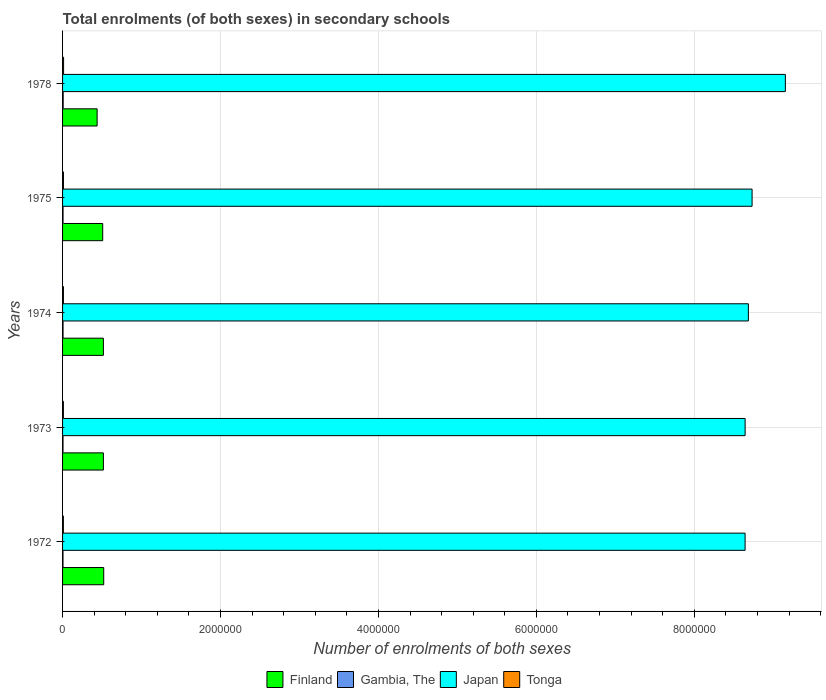How many bars are there on the 4th tick from the top?
Offer a terse response. 4. How many bars are there on the 4th tick from the bottom?
Your answer should be compact. 4. What is the label of the 2nd group of bars from the top?
Your response must be concise. 1975. What is the number of enrolments in secondary schools in Tonga in 1972?
Provide a succinct answer. 1.04e+04. Across all years, what is the maximum number of enrolments in secondary schools in Tonga?
Keep it short and to the point. 1.28e+04. Across all years, what is the minimum number of enrolments in secondary schools in Finland?
Keep it short and to the point. 4.38e+05. In which year was the number of enrolments in secondary schools in Japan maximum?
Make the answer very short. 1978. What is the total number of enrolments in secondary schools in Gambia, The in the graph?
Provide a short and direct response. 3.10e+04. What is the difference between the number of enrolments in secondary schools in Finland in 1973 and that in 1974?
Your response must be concise. -25. What is the difference between the number of enrolments in secondary schools in Gambia, The in 1973 and the number of enrolments in secondary schools in Tonga in 1972?
Make the answer very short. -4580. What is the average number of enrolments in secondary schools in Finland per year?
Provide a short and direct response. 5.00e+05. In the year 1975, what is the difference between the number of enrolments in secondary schools in Finland and number of enrolments in secondary schools in Gambia, The?
Offer a very short reply. 5.02e+05. In how many years, is the number of enrolments in secondary schools in Japan greater than 400000 ?
Keep it short and to the point. 5. What is the ratio of the number of enrolments in secondary schools in Japan in 1972 to that in 1974?
Keep it short and to the point. 1. Is the number of enrolments in secondary schools in Tonga in 1973 less than that in 1975?
Ensure brevity in your answer.  Yes. Is the difference between the number of enrolments in secondary schools in Finland in 1974 and 1978 greater than the difference between the number of enrolments in secondary schools in Gambia, The in 1974 and 1978?
Provide a short and direct response. Yes. What is the difference between the highest and the second highest number of enrolments in secondary schools in Tonga?
Ensure brevity in your answer.  1444. What is the difference between the highest and the lowest number of enrolments in secondary schools in Tonga?
Provide a short and direct response. 2424. Is the sum of the number of enrolments in secondary schools in Tonga in 1974 and 1975 greater than the maximum number of enrolments in secondary schools in Finland across all years?
Provide a short and direct response. No. What does the 3rd bar from the top in 1973 represents?
Give a very brief answer. Gambia, The. What does the 1st bar from the bottom in 1974 represents?
Offer a very short reply. Finland. Is it the case that in every year, the sum of the number of enrolments in secondary schools in Gambia, The and number of enrolments in secondary schools in Tonga is greater than the number of enrolments in secondary schools in Japan?
Offer a terse response. No. Are all the bars in the graph horizontal?
Your answer should be very brief. Yes. What is the difference between two consecutive major ticks on the X-axis?
Your response must be concise. 2.00e+06. Are the values on the major ticks of X-axis written in scientific E-notation?
Ensure brevity in your answer.  No. Does the graph contain grids?
Provide a succinct answer. Yes. What is the title of the graph?
Your answer should be very brief. Total enrolments (of both sexes) in secondary schools. What is the label or title of the X-axis?
Offer a terse response. Number of enrolments of both sexes. What is the Number of enrolments of both sexes in Finland in 1972?
Offer a very short reply. 5.21e+05. What is the Number of enrolments of both sexes in Gambia, The in 1972?
Offer a terse response. 5482. What is the Number of enrolments of both sexes in Japan in 1972?
Ensure brevity in your answer.  8.64e+06. What is the Number of enrolments of both sexes in Tonga in 1972?
Provide a succinct answer. 1.04e+04. What is the Number of enrolments of both sexes of Finland in 1973?
Provide a short and direct response. 5.17e+05. What is the Number of enrolments of both sexes in Gambia, The in 1973?
Offer a very short reply. 5791. What is the Number of enrolments of both sexes of Japan in 1973?
Your answer should be compact. 8.64e+06. What is the Number of enrolments of both sexes of Tonga in 1973?
Offer a very short reply. 1.06e+04. What is the Number of enrolments of both sexes in Finland in 1974?
Your response must be concise. 5.17e+05. What is the Number of enrolments of both sexes in Gambia, The in 1974?
Give a very brief answer. 5997. What is the Number of enrolments of both sexes of Japan in 1974?
Provide a short and direct response. 8.68e+06. What is the Number of enrolments of both sexes in Tonga in 1974?
Your answer should be compact. 1.11e+04. What is the Number of enrolments of both sexes in Finland in 1975?
Ensure brevity in your answer.  5.08e+05. What is the Number of enrolments of both sexes of Gambia, The in 1975?
Provide a succinct answer. 6162. What is the Number of enrolments of both sexes in Japan in 1975?
Provide a short and direct response. 8.73e+06. What is the Number of enrolments of both sexes of Tonga in 1975?
Your answer should be very brief. 1.14e+04. What is the Number of enrolments of both sexes of Finland in 1978?
Your answer should be very brief. 4.38e+05. What is the Number of enrolments of both sexes of Gambia, The in 1978?
Provide a short and direct response. 7588. What is the Number of enrolments of both sexes in Japan in 1978?
Your answer should be very brief. 9.15e+06. What is the Number of enrolments of both sexes in Tonga in 1978?
Ensure brevity in your answer.  1.28e+04. Across all years, what is the maximum Number of enrolments of both sexes in Finland?
Give a very brief answer. 5.21e+05. Across all years, what is the maximum Number of enrolments of both sexes in Gambia, The?
Keep it short and to the point. 7588. Across all years, what is the maximum Number of enrolments of both sexes in Japan?
Ensure brevity in your answer.  9.15e+06. Across all years, what is the maximum Number of enrolments of both sexes in Tonga?
Your answer should be compact. 1.28e+04. Across all years, what is the minimum Number of enrolments of both sexes of Finland?
Offer a terse response. 4.38e+05. Across all years, what is the minimum Number of enrolments of both sexes of Gambia, The?
Your response must be concise. 5482. Across all years, what is the minimum Number of enrolments of both sexes of Japan?
Your answer should be very brief. 8.64e+06. Across all years, what is the minimum Number of enrolments of both sexes of Tonga?
Your answer should be very brief. 1.04e+04. What is the total Number of enrolments of both sexes of Finland in the graph?
Provide a short and direct response. 2.50e+06. What is the total Number of enrolments of both sexes of Gambia, The in the graph?
Provide a short and direct response. 3.10e+04. What is the total Number of enrolments of both sexes in Japan in the graph?
Give a very brief answer. 4.39e+07. What is the total Number of enrolments of both sexes of Tonga in the graph?
Offer a very short reply. 5.61e+04. What is the difference between the Number of enrolments of both sexes in Finland in 1972 and that in 1973?
Offer a terse response. 4213. What is the difference between the Number of enrolments of both sexes of Gambia, The in 1972 and that in 1973?
Provide a short and direct response. -309. What is the difference between the Number of enrolments of both sexes in Japan in 1972 and that in 1973?
Give a very brief answer. -497. What is the difference between the Number of enrolments of both sexes of Tonga in 1972 and that in 1973?
Your response must be concise. -181. What is the difference between the Number of enrolments of both sexes of Finland in 1972 and that in 1974?
Your response must be concise. 4188. What is the difference between the Number of enrolments of both sexes in Gambia, The in 1972 and that in 1974?
Provide a short and direct response. -515. What is the difference between the Number of enrolments of both sexes of Japan in 1972 and that in 1974?
Your answer should be compact. -4.16e+04. What is the difference between the Number of enrolments of both sexes in Tonga in 1972 and that in 1974?
Offer a very short reply. -681. What is the difference between the Number of enrolments of both sexes of Finland in 1972 and that in 1975?
Give a very brief answer. 1.30e+04. What is the difference between the Number of enrolments of both sexes in Gambia, The in 1972 and that in 1975?
Keep it short and to the point. -680. What is the difference between the Number of enrolments of both sexes of Japan in 1972 and that in 1975?
Provide a short and direct response. -8.85e+04. What is the difference between the Number of enrolments of both sexes of Tonga in 1972 and that in 1975?
Provide a short and direct response. -980. What is the difference between the Number of enrolments of both sexes in Finland in 1972 and that in 1978?
Your answer should be compact. 8.35e+04. What is the difference between the Number of enrolments of both sexes of Gambia, The in 1972 and that in 1978?
Keep it short and to the point. -2106. What is the difference between the Number of enrolments of both sexes of Japan in 1972 and that in 1978?
Give a very brief answer. -5.10e+05. What is the difference between the Number of enrolments of both sexes in Tonga in 1972 and that in 1978?
Offer a terse response. -2424. What is the difference between the Number of enrolments of both sexes of Finland in 1973 and that in 1974?
Give a very brief answer. -25. What is the difference between the Number of enrolments of both sexes of Gambia, The in 1973 and that in 1974?
Your answer should be compact. -206. What is the difference between the Number of enrolments of both sexes in Japan in 1973 and that in 1974?
Make the answer very short. -4.11e+04. What is the difference between the Number of enrolments of both sexes of Tonga in 1973 and that in 1974?
Your response must be concise. -500. What is the difference between the Number of enrolments of both sexes in Finland in 1973 and that in 1975?
Your response must be concise. 8749. What is the difference between the Number of enrolments of both sexes of Gambia, The in 1973 and that in 1975?
Ensure brevity in your answer.  -371. What is the difference between the Number of enrolments of both sexes of Japan in 1973 and that in 1975?
Give a very brief answer. -8.80e+04. What is the difference between the Number of enrolments of both sexes of Tonga in 1973 and that in 1975?
Your answer should be compact. -799. What is the difference between the Number of enrolments of both sexes in Finland in 1973 and that in 1978?
Offer a very short reply. 7.93e+04. What is the difference between the Number of enrolments of both sexes of Gambia, The in 1973 and that in 1978?
Offer a terse response. -1797. What is the difference between the Number of enrolments of both sexes of Japan in 1973 and that in 1978?
Keep it short and to the point. -5.09e+05. What is the difference between the Number of enrolments of both sexes of Tonga in 1973 and that in 1978?
Make the answer very short. -2243. What is the difference between the Number of enrolments of both sexes in Finland in 1974 and that in 1975?
Ensure brevity in your answer.  8774. What is the difference between the Number of enrolments of both sexes in Gambia, The in 1974 and that in 1975?
Your answer should be very brief. -165. What is the difference between the Number of enrolments of both sexes in Japan in 1974 and that in 1975?
Your answer should be very brief. -4.69e+04. What is the difference between the Number of enrolments of both sexes in Tonga in 1974 and that in 1975?
Offer a terse response. -299. What is the difference between the Number of enrolments of both sexes of Finland in 1974 and that in 1978?
Provide a short and direct response. 7.93e+04. What is the difference between the Number of enrolments of both sexes of Gambia, The in 1974 and that in 1978?
Your answer should be very brief. -1591. What is the difference between the Number of enrolments of both sexes in Japan in 1974 and that in 1978?
Your answer should be very brief. -4.68e+05. What is the difference between the Number of enrolments of both sexes in Tonga in 1974 and that in 1978?
Provide a succinct answer. -1743. What is the difference between the Number of enrolments of both sexes of Finland in 1975 and that in 1978?
Make the answer very short. 7.05e+04. What is the difference between the Number of enrolments of both sexes of Gambia, The in 1975 and that in 1978?
Provide a short and direct response. -1426. What is the difference between the Number of enrolments of both sexes in Japan in 1975 and that in 1978?
Your response must be concise. -4.21e+05. What is the difference between the Number of enrolments of both sexes in Tonga in 1975 and that in 1978?
Your answer should be very brief. -1444. What is the difference between the Number of enrolments of both sexes in Finland in 1972 and the Number of enrolments of both sexes in Gambia, The in 1973?
Your answer should be compact. 5.15e+05. What is the difference between the Number of enrolments of both sexes in Finland in 1972 and the Number of enrolments of both sexes in Japan in 1973?
Your response must be concise. -8.12e+06. What is the difference between the Number of enrolments of both sexes of Finland in 1972 and the Number of enrolments of both sexes of Tonga in 1973?
Your answer should be compact. 5.11e+05. What is the difference between the Number of enrolments of both sexes of Gambia, The in 1972 and the Number of enrolments of both sexes of Japan in 1973?
Ensure brevity in your answer.  -8.64e+06. What is the difference between the Number of enrolments of both sexes of Gambia, The in 1972 and the Number of enrolments of both sexes of Tonga in 1973?
Ensure brevity in your answer.  -5070. What is the difference between the Number of enrolments of both sexes of Japan in 1972 and the Number of enrolments of both sexes of Tonga in 1973?
Provide a succinct answer. 8.63e+06. What is the difference between the Number of enrolments of both sexes in Finland in 1972 and the Number of enrolments of both sexes in Gambia, The in 1974?
Give a very brief answer. 5.15e+05. What is the difference between the Number of enrolments of both sexes of Finland in 1972 and the Number of enrolments of both sexes of Japan in 1974?
Keep it short and to the point. -8.16e+06. What is the difference between the Number of enrolments of both sexes of Finland in 1972 and the Number of enrolments of both sexes of Tonga in 1974?
Your answer should be compact. 5.10e+05. What is the difference between the Number of enrolments of both sexes of Gambia, The in 1972 and the Number of enrolments of both sexes of Japan in 1974?
Offer a terse response. -8.68e+06. What is the difference between the Number of enrolments of both sexes of Gambia, The in 1972 and the Number of enrolments of both sexes of Tonga in 1974?
Your answer should be compact. -5570. What is the difference between the Number of enrolments of both sexes in Japan in 1972 and the Number of enrolments of both sexes in Tonga in 1974?
Give a very brief answer. 8.63e+06. What is the difference between the Number of enrolments of both sexes of Finland in 1972 and the Number of enrolments of both sexes of Gambia, The in 1975?
Your response must be concise. 5.15e+05. What is the difference between the Number of enrolments of both sexes of Finland in 1972 and the Number of enrolments of both sexes of Japan in 1975?
Make the answer very short. -8.21e+06. What is the difference between the Number of enrolments of both sexes in Finland in 1972 and the Number of enrolments of both sexes in Tonga in 1975?
Keep it short and to the point. 5.10e+05. What is the difference between the Number of enrolments of both sexes of Gambia, The in 1972 and the Number of enrolments of both sexes of Japan in 1975?
Offer a terse response. -8.73e+06. What is the difference between the Number of enrolments of both sexes of Gambia, The in 1972 and the Number of enrolments of both sexes of Tonga in 1975?
Your answer should be compact. -5869. What is the difference between the Number of enrolments of both sexes in Japan in 1972 and the Number of enrolments of both sexes in Tonga in 1975?
Provide a short and direct response. 8.63e+06. What is the difference between the Number of enrolments of both sexes of Finland in 1972 and the Number of enrolments of both sexes of Gambia, The in 1978?
Offer a very short reply. 5.14e+05. What is the difference between the Number of enrolments of both sexes in Finland in 1972 and the Number of enrolments of both sexes in Japan in 1978?
Provide a succinct answer. -8.63e+06. What is the difference between the Number of enrolments of both sexes of Finland in 1972 and the Number of enrolments of both sexes of Tonga in 1978?
Provide a succinct answer. 5.08e+05. What is the difference between the Number of enrolments of both sexes in Gambia, The in 1972 and the Number of enrolments of both sexes in Japan in 1978?
Your answer should be very brief. -9.15e+06. What is the difference between the Number of enrolments of both sexes of Gambia, The in 1972 and the Number of enrolments of both sexes of Tonga in 1978?
Provide a short and direct response. -7313. What is the difference between the Number of enrolments of both sexes in Japan in 1972 and the Number of enrolments of both sexes in Tonga in 1978?
Offer a very short reply. 8.63e+06. What is the difference between the Number of enrolments of both sexes in Finland in 1973 and the Number of enrolments of both sexes in Gambia, The in 1974?
Your answer should be very brief. 5.11e+05. What is the difference between the Number of enrolments of both sexes of Finland in 1973 and the Number of enrolments of both sexes of Japan in 1974?
Offer a very short reply. -8.17e+06. What is the difference between the Number of enrolments of both sexes of Finland in 1973 and the Number of enrolments of both sexes of Tonga in 1974?
Provide a short and direct response. 5.06e+05. What is the difference between the Number of enrolments of both sexes in Gambia, The in 1973 and the Number of enrolments of both sexes in Japan in 1974?
Your answer should be very brief. -8.68e+06. What is the difference between the Number of enrolments of both sexes of Gambia, The in 1973 and the Number of enrolments of both sexes of Tonga in 1974?
Keep it short and to the point. -5261. What is the difference between the Number of enrolments of both sexes of Japan in 1973 and the Number of enrolments of both sexes of Tonga in 1974?
Offer a very short reply. 8.63e+06. What is the difference between the Number of enrolments of both sexes in Finland in 1973 and the Number of enrolments of both sexes in Gambia, The in 1975?
Keep it short and to the point. 5.11e+05. What is the difference between the Number of enrolments of both sexes in Finland in 1973 and the Number of enrolments of both sexes in Japan in 1975?
Offer a very short reply. -8.21e+06. What is the difference between the Number of enrolments of both sexes of Finland in 1973 and the Number of enrolments of both sexes of Tonga in 1975?
Your answer should be compact. 5.06e+05. What is the difference between the Number of enrolments of both sexes in Gambia, The in 1973 and the Number of enrolments of both sexes in Japan in 1975?
Keep it short and to the point. -8.73e+06. What is the difference between the Number of enrolments of both sexes of Gambia, The in 1973 and the Number of enrolments of both sexes of Tonga in 1975?
Your response must be concise. -5560. What is the difference between the Number of enrolments of both sexes of Japan in 1973 and the Number of enrolments of both sexes of Tonga in 1975?
Your answer should be very brief. 8.63e+06. What is the difference between the Number of enrolments of both sexes in Finland in 1973 and the Number of enrolments of both sexes in Gambia, The in 1978?
Provide a succinct answer. 5.09e+05. What is the difference between the Number of enrolments of both sexes of Finland in 1973 and the Number of enrolments of both sexes of Japan in 1978?
Provide a succinct answer. -8.64e+06. What is the difference between the Number of enrolments of both sexes in Finland in 1973 and the Number of enrolments of both sexes in Tonga in 1978?
Give a very brief answer. 5.04e+05. What is the difference between the Number of enrolments of both sexes of Gambia, The in 1973 and the Number of enrolments of both sexes of Japan in 1978?
Keep it short and to the point. -9.15e+06. What is the difference between the Number of enrolments of both sexes of Gambia, The in 1973 and the Number of enrolments of both sexes of Tonga in 1978?
Offer a terse response. -7004. What is the difference between the Number of enrolments of both sexes in Japan in 1973 and the Number of enrolments of both sexes in Tonga in 1978?
Provide a short and direct response. 8.63e+06. What is the difference between the Number of enrolments of both sexes in Finland in 1974 and the Number of enrolments of both sexes in Gambia, The in 1975?
Ensure brevity in your answer.  5.11e+05. What is the difference between the Number of enrolments of both sexes in Finland in 1974 and the Number of enrolments of both sexes in Japan in 1975?
Give a very brief answer. -8.21e+06. What is the difference between the Number of enrolments of both sexes of Finland in 1974 and the Number of enrolments of both sexes of Tonga in 1975?
Ensure brevity in your answer.  5.06e+05. What is the difference between the Number of enrolments of both sexes of Gambia, The in 1974 and the Number of enrolments of both sexes of Japan in 1975?
Provide a short and direct response. -8.73e+06. What is the difference between the Number of enrolments of both sexes in Gambia, The in 1974 and the Number of enrolments of both sexes in Tonga in 1975?
Make the answer very short. -5354. What is the difference between the Number of enrolments of both sexes of Japan in 1974 and the Number of enrolments of both sexes of Tonga in 1975?
Your answer should be compact. 8.67e+06. What is the difference between the Number of enrolments of both sexes of Finland in 1974 and the Number of enrolments of both sexes of Gambia, The in 1978?
Provide a succinct answer. 5.09e+05. What is the difference between the Number of enrolments of both sexes in Finland in 1974 and the Number of enrolments of both sexes in Japan in 1978?
Ensure brevity in your answer.  -8.64e+06. What is the difference between the Number of enrolments of both sexes of Finland in 1974 and the Number of enrolments of both sexes of Tonga in 1978?
Provide a succinct answer. 5.04e+05. What is the difference between the Number of enrolments of both sexes of Gambia, The in 1974 and the Number of enrolments of both sexes of Japan in 1978?
Give a very brief answer. -9.15e+06. What is the difference between the Number of enrolments of both sexes of Gambia, The in 1974 and the Number of enrolments of both sexes of Tonga in 1978?
Your answer should be very brief. -6798. What is the difference between the Number of enrolments of both sexes in Japan in 1974 and the Number of enrolments of both sexes in Tonga in 1978?
Your response must be concise. 8.67e+06. What is the difference between the Number of enrolments of both sexes in Finland in 1975 and the Number of enrolments of both sexes in Gambia, The in 1978?
Provide a succinct answer. 5.01e+05. What is the difference between the Number of enrolments of both sexes of Finland in 1975 and the Number of enrolments of both sexes of Japan in 1978?
Offer a very short reply. -8.64e+06. What is the difference between the Number of enrolments of both sexes in Finland in 1975 and the Number of enrolments of both sexes in Tonga in 1978?
Make the answer very short. 4.95e+05. What is the difference between the Number of enrolments of both sexes in Gambia, The in 1975 and the Number of enrolments of both sexes in Japan in 1978?
Give a very brief answer. -9.15e+06. What is the difference between the Number of enrolments of both sexes in Gambia, The in 1975 and the Number of enrolments of both sexes in Tonga in 1978?
Offer a terse response. -6633. What is the difference between the Number of enrolments of both sexes of Japan in 1975 and the Number of enrolments of both sexes of Tonga in 1978?
Make the answer very short. 8.72e+06. What is the average Number of enrolments of both sexes in Finland per year?
Your response must be concise. 5.00e+05. What is the average Number of enrolments of both sexes of Gambia, The per year?
Provide a short and direct response. 6204. What is the average Number of enrolments of both sexes of Japan per year?
Ensure brevity in your answer.  8.77e+06. What is the average Number of enrolments of both sexes in Tonga per year?
Offer a very short reply. 1.12e+04. In the year 1972, what is the difference between the Number of enrolments of both sexes in Finland and Number of enrolments of both sexes in Gambia, The?
Your answer should be very brief. 5.16e+05. In the year 1972, what is the difference between the Number of enrolments of both sexes in Finland and Number of enrolments of both sexes in Japan?
Make the answer very short. -8.12e+06. In the year 1972, what is the difference between the Number of enrolments of both sexes in Finland and Number of enrolments of both sexes in Tonga?
Your response must be concise. 5.11e+05. In the year 1972, what is the difference between the Number of enrolments of both sexes of Gambia, The and Number of enrolments of both sexes of Japan?
Give a very brief answer. -8.64e+06. In the year 1972, what is the difference between the Number of enrolments of both sexes of Gambia, The and Number of enrolments of both sexes of Tonga?
Provide a succinct answer. -4889. In the year 1972, what is the difference between the Number of enrolments of both sexes of Japan and Number of enrolments of both sexes of Tonga?
Your response must be concise. 8.63e+06. In the year 1973, what is the difference between the Number of enrolments of both sexes of Finland and Number of enrolments of both sexes of Gambia, The?
Provide a short and direct response. 5.11e+05. In the year 1973, what is the difference between the Number of enrolments of both sexes of Finland and Number of enrolments of both sexes of Japan?
Make the answer very short. -8.13e+06. In the year 1973, what is the difference between the Number of enrolments of both sexes in Finland and Number of enrolments of both sexes in Tonga?
Offer a terse response. 5.06e+05. In the year 1973, what is the difference between the Number of enrolments of both sexes of Gambia, The and Number of enrolments of both sexes of Japan?
Provide a short and direct response. -8.64e+06. In the year 1973, what is the difference between the Number of enrolments of both sexes of Gambia, The and Number of enrolments of both sexes of Tonga?
Your answer should be compact. -4761. In the year 1973, what is the difference between the Number of enrolments of both sexes in Japan and Number of enrolments of both sexes in Tonga?
Provide a short and direct response. 8.63e+06. In the year 1974, what is the difference between the Number of enrolments of both sexes in Finland and Number of enrolments of both sexes in Gambia, The?
Your response must be concise. 5.11e+05. In the year 1974, what is the difference between the Number of enrolments of both sexes of Finland and Number of enrolments of both sexes of Japan?
Provide a succinct answer. -8.17e+06. In the year 1974, what is the difference between the Number of enrolments of both sexes in Finland and Number of enrolments of both sexes in Tonga?
Your answer should be compact. 5.06e+05. In the year 1974, what is the difference between the Number of enrolments of both sexes of Gambia, The and Number of enrolments of both sexes of Japan?
Offer a terse response. -8.68e+06. In the year 1974, what is the difference between the Number of enrolments of both sexes of Gambia, The and Number of enrolments of both sexes of Tonga?
Ensure brevity in your answer.  -5055. In the year 1974, what is the difference between the Number of enrolments of both sexes of Japan and Number of enrolments of both sexes of Tonga?
Offer a terse response. 8.67e+06. In the year 1975, what is the difference between the Number of enrolments of both sexes of Finland and Number of enrolments of both sexes of Gambia, The?
Provide a succinct answer. 5.02e+05. In the year 1975, what is the difference between the Number of enrolments of both sexes of Finland and Number of enrolments of both sexes of Japan?
Your answer should be very brief. -8.22e+06. In the year 1975, what is the difference between the Number of enrolments of both sexes of Finland and Number of enrolments of both sexes of Tonga?
Ensure brevity in your answer.  4.97e+05. In the year 1975, what is the difference between the Number of enrolments of both sexes in Gambia, The and Number of enrolments of both sexes in Japan?
Provide a short and direct response. -8.73e+06. In the year 1975, what is the difference between the Number of enrolments of both sexes of Gambia, The and Number of enrolments of both sexes of Tonga?
Your response must be concise. -5189. In the year 1975, what is the difference between the Number of enrolments of both sexes in Japan and Number of enrolments of both sexes in Tonga?
Your answer should be very brief. 8.72e+06. In the year 1978, what is the difference between the Number of enrolments of both sexes in Finland and Number of enrolments of both sexes in Gambia, The?
Offer a very short reply. 4.30e+05. In the year 1978, what is the difference between the Number of enrolments of both sexes of Finland and Number of enrolments of both sexes of Japan?
Make the answer very short. -8.72e+06. In the year 1978, what is the difference between the Number of enrolments of both sexes in Finland and Number of enrolments of both sexes in Tonga?
Your response must be concise. 4.25e+05. In the year 1978, what is the difference between the Number of enrolments of both sexes of Gambia, The and Number of enrolments of both sexes of Japan?
Keep it short and to the point. -9.15e+06. In the year 1978, what is the difference between the Number of enrolments of both sexes of Gambia, The and Number of enrolments of both sexes of Tonga?
Provide a short and direct response. -5207. In the year 1978, what is the difference between the Number of enrolments of both sexes in Japan and Number of enrolments of both sexes in Tonga?
Offer a very short reply. 9.14e+06. What is the ratio of the Number of enrolments of both sexes of Finland in 1972 to that in 1973?
Offer a very short reply. 1.01. What is the ratio of the Number of enrolments of both sexes in Gambia, The in 1972 to that in 1973?
Give a very brief answer. 0.95. What is the ratio of the Number of enrolments of both sexes in Tonga in 1972 to that in 1973?
Your answer should be compact. 0.98. What is the ratio of the Number of enrolments of both sexes in Gambia, The in 1972 to that in 1974?
Offer a terse response. 0.91. What is the ratio of the Number of enrolments of both sexes in Tonga in 1972 to that in 1974?
Your answer should be very brief. 0.94. What is the ratio of the Number of enrolments of both sexes in Finland in 1972 to that in 1975?
Give a very brief answer. 1.03. What is the ratio of the Number of enrolments of both sexes of Gambia, The in 1972 to that in 1975?
Offer a very short reply. 0.89. What is the ratio of the Number of enrolments of both sexes of Japan in 1972 to that in 1975?
Your answer should be very brief. 0.99. What is the ratio of the Number of enrolments of both sexes of Tonga in 1972 to that in 1975?
Give a very brief answer. 0.91. What is the ratio of the Number of enrolments of both sexes of Finland in 1972 to that in 1978?
Make the answer very short. 1.19. What is the ratio of the Number of enrolments of both sexes in Gambia, The in 1972 to that in 1978?
Your response must be concise. 0.72. What is the ratio of the Number of enrolments of both sexes in Japan in 1972 to that in 1978?
Your answer should be compact. 0.94. What is the ratio of the Number of enrolments of both sexes in Tonga in 1972 to that in 1978?
Your response must be concise. 0.81. What is the ratio of the Number of enrolments of both sexes in Gambia, The in 1973 to that in 1974?
Your answer should be compact. 0.97. What is the ratio of the Number of enrolments of both sexes of Japan in 1973 to that in 1974?
Your answer should be very brief. 1. What is the ratio of the Number of enrolments of both sexes of Tonga in 1973 to that in 1974?
Offer a terse response. 0.95. What is the ratio of the Number of enrolments of both sexes in Finland in 1973 to that in 1975?
Provide a succinct answer. 1.02. What is the ratio of the Number of enrolments of both sexes in Gambia, The in 1973 to that in 1975?
Give a very brief answer. 0.94. What is the ratio of the Number of enrolments of both sexes of Tonga in 1973 to that in 1975?
Give a very brief answer. 0.93. What is the ratio of the Number of enrolments of both sexes of Finland in 1973 to that in 1978?
Your response must be concise. 1.18. What is the ratio of the Number of enrolments of both sexes of Gambia, The in 1973 to that in 1978?
Keep it short and to the point. 0.76. What is the ratio of the Number of enrolments of both sexes of Tonga in 1973 to that in 1978?
Ensure brevity in your answer.  0.82. What is the ratio of the Number of enrolments of both sexes in Finland in 1974 to that in 1975?
Give a very brief answer. 1.02. What is the ratio of the Number of enrolments of both sexes of Gambia, The in 1974 to that in 1975?
Your response must be concise. 0.97. What is the ratio of the Number of enrolments of both sexes in Japan in 1974 to that in 1975?
Provide a succinct answer. 0.99. What is the ratio of the Number of enrolments of both sexes of Tonga in 1974 to that in 1975?
Your response must be concise. 0.97. What is the ratio of the Number of enrolments of both sexes of Finland in 1974 to that in 1978?
Provide a succinct answer. 1.18. What is the ratio of the Number of enrolments of both sexes in Gambia, The in 1974 to that in 1978?
Provide a succinct answer. 0.79. What is the ratio of the Number of enrolments of both sexes in Japan in 1974 to that in 1978?
Your answer should be compact. 0.95. What is the ratio of the Number of enrolments of both sexes in Tonga in 1974 to that in 1978?
Your answer should be compact. 0.86. What is the ratio of the Number of enrolments of both sexes of Finland in 1975 to that in 1978?
Offer a very short reply. 1.16. What is the ratio of the Number of enrolments of both sexes in Gambia, The in 1975 to that in 1978?
Your response must be concise. 0.81. What is the ratio of the Number of enrolments of both sexes in Japan in 1975 to that in 1978?
Make the answer very short. 0.95. What is the ratio of the Number of enrolments of both sexes in Tonga in 1975 to that in 1978?
Provide a short and direct response. 0.89. What is the difference between the highest and the second highest Number of enrolments of both sexes of Finland?
Your answer should be compact. 4188. What is the difference between the highest and the second highest Number of enrolments of both sexes in Gambia, The?
Your answer should be compact. 1426. What is the difference between the highest and the second highest Number of enrolments of both sexes of Japan?
Give a very brief answer. 4.21e+05. What is the difference between the highest and the second highest Number of enrolments of both sexes of Tonga?
Offer a terse response. 1444. What is the difference between the highest and the lowest Number of enrolments of both sexes of Finland?
Ensure brevity in your answer.  8.35e+04. What is the difference between the highest and the lowest Number of enrolments of both sexes in Gambia, The?
Your response must be concise. 2106. What is the difference between the highest and the lowest Number of enrolments of both sexes of Japan?
Give a very brief answer. 5.10e+05. What is the difference between the highest and the lowest Number of enrolments of both sexes in Tonga?
Make the answer very short. 2424. 